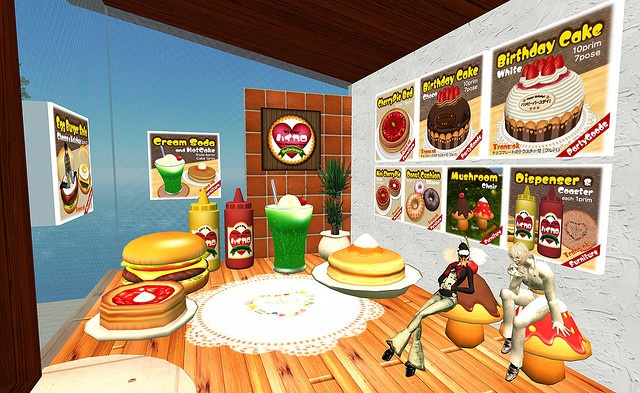Describe the objects in this image and their specific colors. I can see dining table in maroon, white, orange, and red tones, cake in maroon, ivory, tan, and brown tones, sandwich in maroon, orange, gold, and brown tones, cake in maroon, orange, and red tones, and cake in maroon, gold, khaki, orange, and ivory tones in this image. 